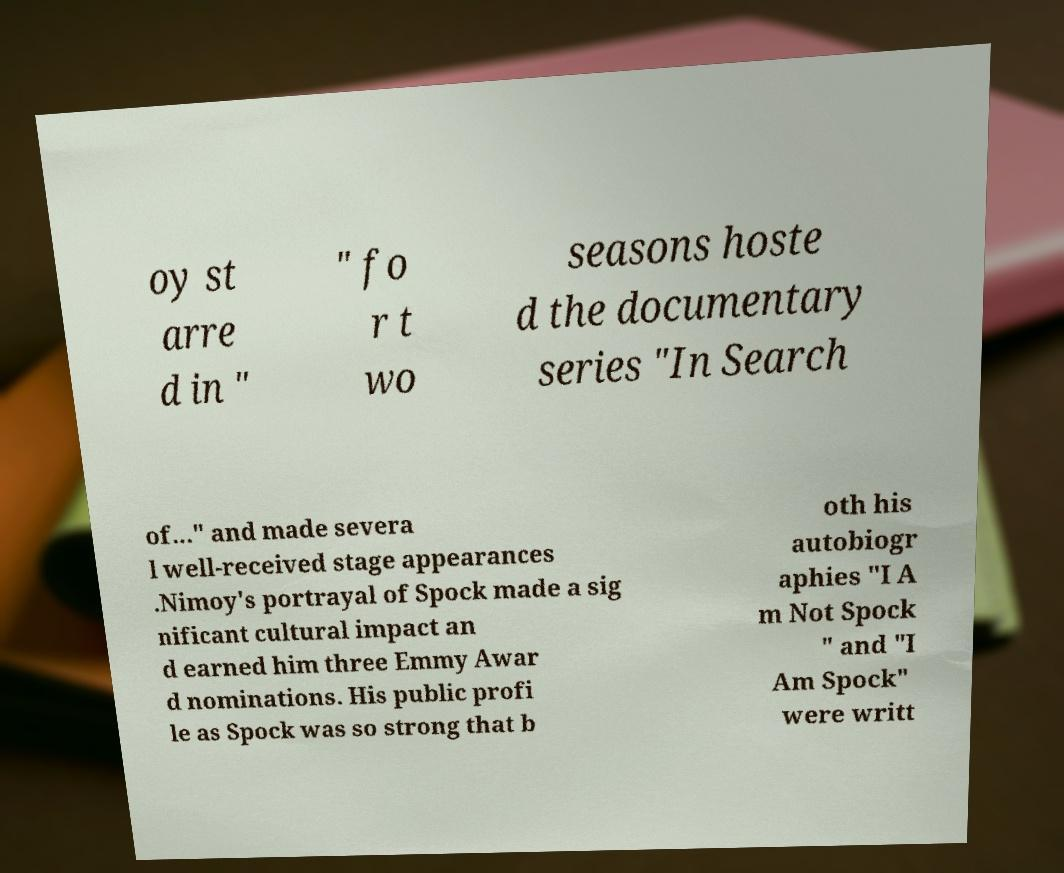There's text embedded in this image that I need extracted. Can you transcribe it verbatim? oy st arre d in " " fo r t wo seasons hoste d the documentary series "In Search of..." and made severa l well-received stage appearances .Nimoy's portrayal of Spock made a sig nificant cultural impact an d earned him three Emmy Awar d nominations. His public profi le as Spock was so strong that b oth his autobiogr aphies "I A m Not Spock " and "I Am Spock" were writt 